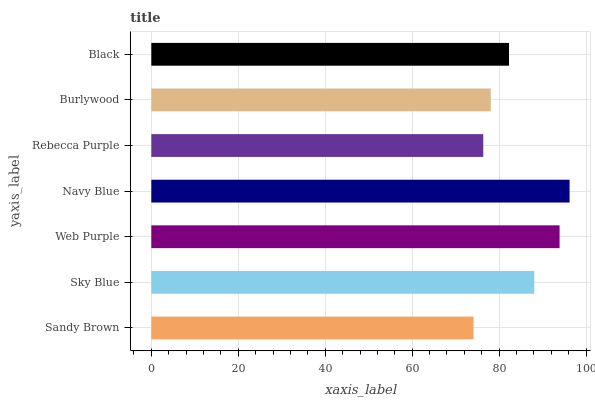Is Sandy Brown the minimum?
Answer yes or no. Yes. Is Navy Blue the maximum?
Answer yes or no. Yes. Is Sky Blue the minimum?
Answer yes or no. No. Is Sky Blue the maximum?
Answer yes or no. No. Is Sky Blue greater than Sandy Brown?
Answer yes or no. Yes. Is Sandy Brown less than Sky Blue?
Answer yes or no. Yes. Is Sandy Brown greater than Sky Blue?
Answer yes or no. No. Is Sky Blue less than Sandy Brown?
Answer yes or no. No. Is Black the high median?
Answer yes or no. Yes. Is Black the low median?
Answer yes or no. Yes. Is Sky Blue the high median?
Answer yes or no. No. Is Sandy Brown the low median?
Answer yes or no. No. 